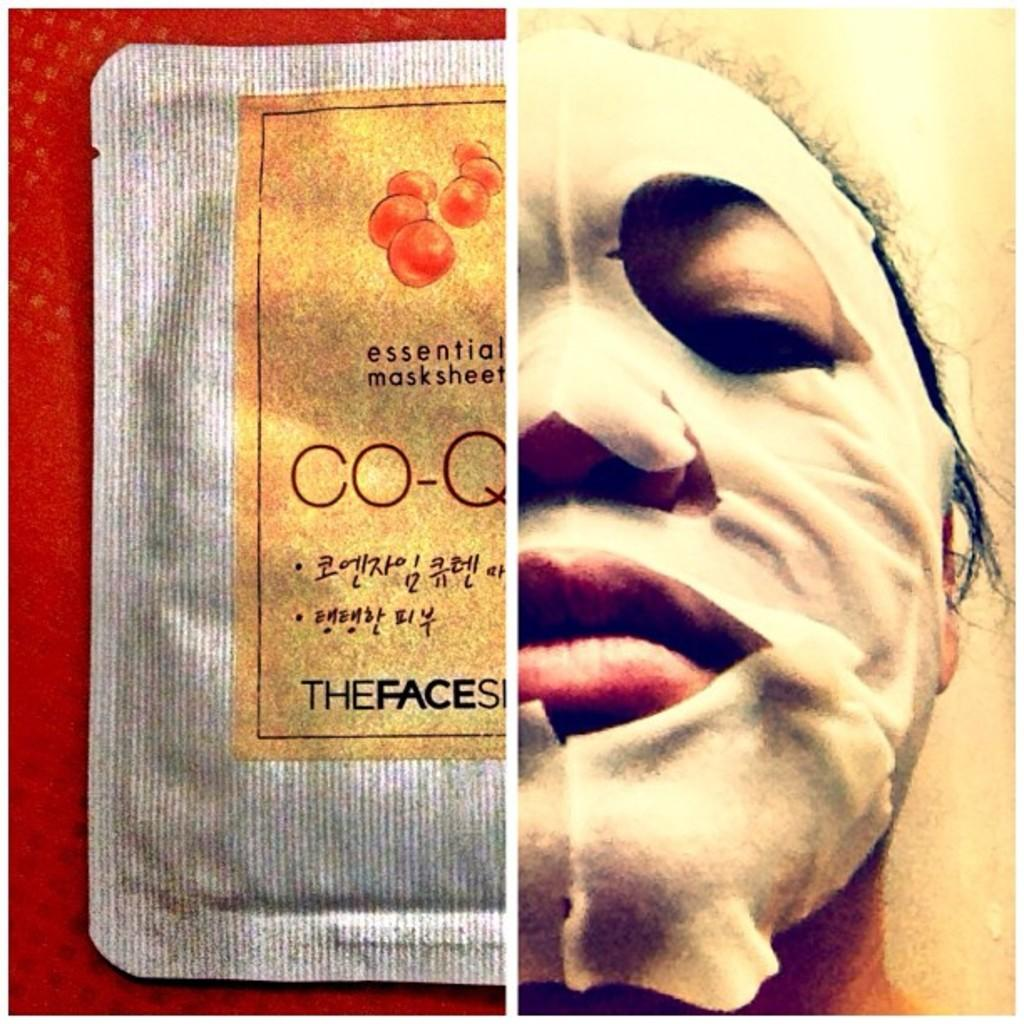What type of artwork is depicted in the image? The image is a collage. What can be seen on the left side of the collage? There is a pouch with text on the left side of the collage. What is featured on the right side of the collage? There is a face of a person with a mask on the right side of the collage. What year is depicted in the sky in the image? There is no sky or year present in the image; it is a collage featuring a pouch with text and a face with a mask. 